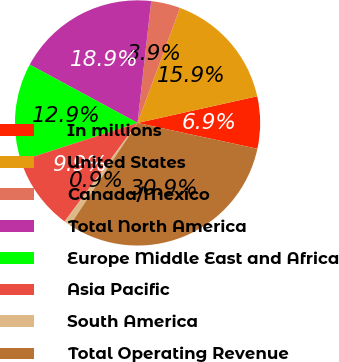Convert chart to OTSL. <chart><loc_0><loc_0><loc_500><loc_500><pie_chart><fcel>In millions<fcel>United States<fcel>Canada/Mexico<fcel>Total North America<fcel>Europe Middle East and Africa<fcel>Asia Pacific<fcel>South America<fcel>Total Operating Revenue<nl><fcel>6.87%<fcel>15.88%<fcel>3.86%<fcel>18.89%<fcel>12.88%<fcel>9.87%<fcel>0.86%<fcel>30.91%<nl></chart> 